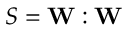Convert formula to latex. <formula><loc_0><loc_0><loc_500><loc_500>S = W \colon W</formula> 